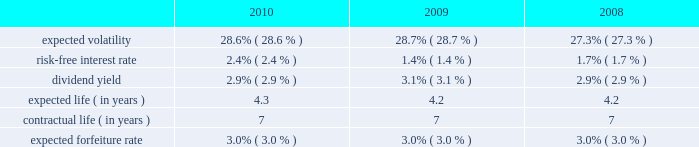2006 plan prior to december 5 , 2008 became fully vested and nonforfeitable upon the closing of the acquisition .
Awards may be granted under the 2006 plan , as amended and restated , after december 5 , 2008 only to employees and consultants of allied waste industries , inc .
And its subsidiaries who were not employed by republic services , inc .
Prior to such date .
At december 31 , 2010 , there were approximately 15.3 million shares of common stock reserved for future grants under the 2006 plan .
Stock options we use a binomial option-pricing model to value our stock option grants .
We recognize compensation expense on a straight-line basis over the requisite service period for each separately vesting portion of the award , or to the employee 2019s retirement eligible date , if earlier .
Expected volatility is based on the weighted average of the most recent one-year volatility and a historical rolling average volatility of our stock over the expected life of the option .
The risk-free interest rate is based on federal reserve rates in effect for bonds with maturity dates equal to the expected term of the option .
We use historical data to estimate future option exercises , forfeitures and expected life of the options .
When appropriate , separate groups of employees that have similar historical exercise behavior are considered separately for valuation purposes .
The weighted-average estimated fair values of stock options granted during the years ended december 31 , 2010 , 2009 and 2008 were $ 5.28 , $ 3.79 and $ 4.36 per option , respectively , which were calculated using the following weighted-average assumptions: .
Republic services , inc .
Notes to consolidated financial statements , continued .
What was the percentage growth in the weighted-average estimated fair values of stock options granted from 2009 to 2010? 
Rationale: the weighted-average estimated fair values of stock options granted from 2009 to 2010 increased by 39.3%
Computations: ((5.28 - 3.79) / 3.79)
Answer: 0.39314. 